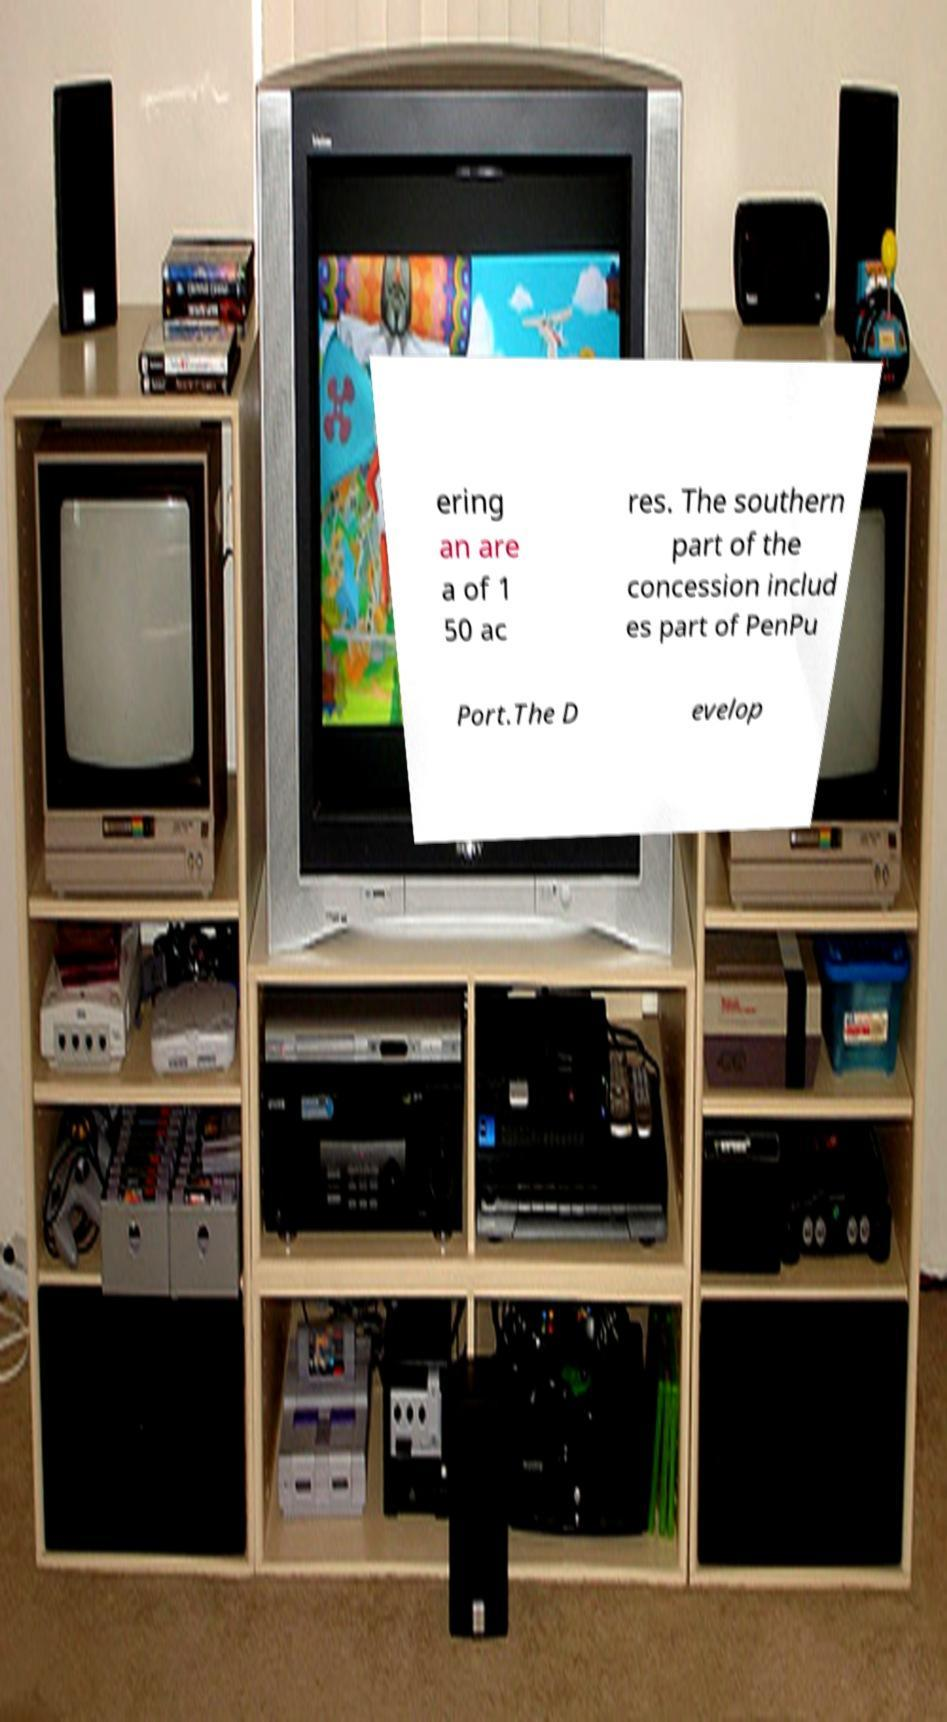There's text embedded in this image that I need extracted. Can you transcribe it verbatim? ering an are a of 1 50 ac res. The southern part of the concession includ es part of PenPu Port.The D evelop 